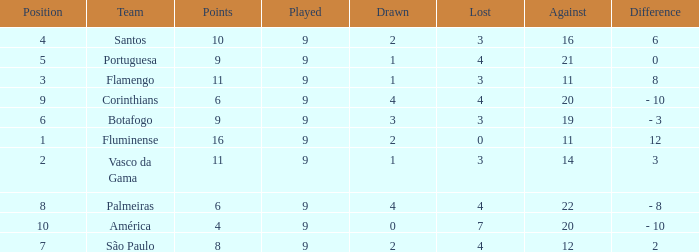Which Points is the highest one that has a Position of 1, and a Lost smaller than 0? None. 